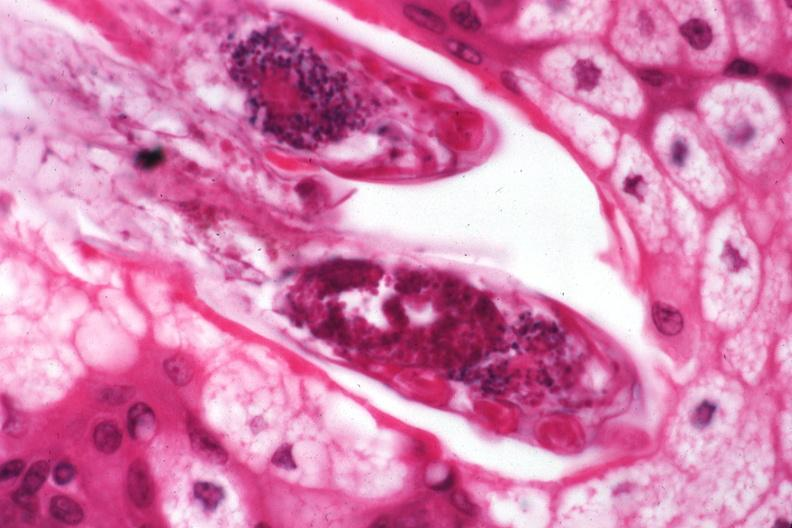what does this image show?
Answer the question using a single word or phrase. Demodex folliculorum 